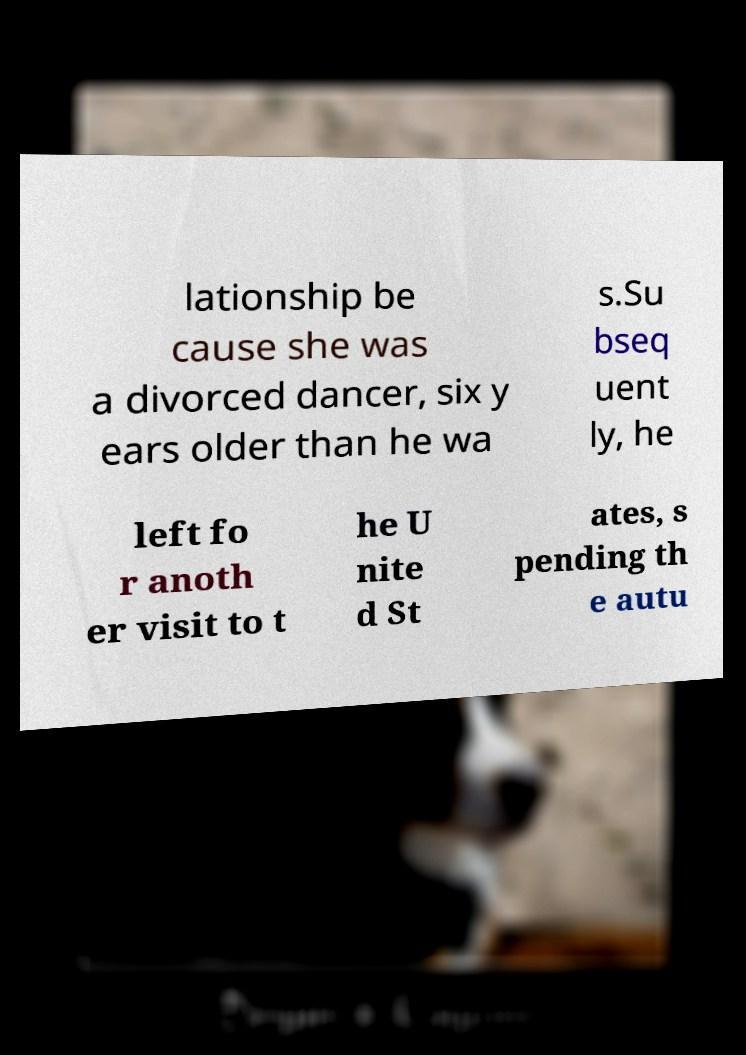Please identify and transcribe the text found in this image. lationship be cause she was a divorced dancer, six y ears older than he wa s.Su bseq uent ly, he left fo r anoth er visit to t he U nite d St ates, s pending th e autu 